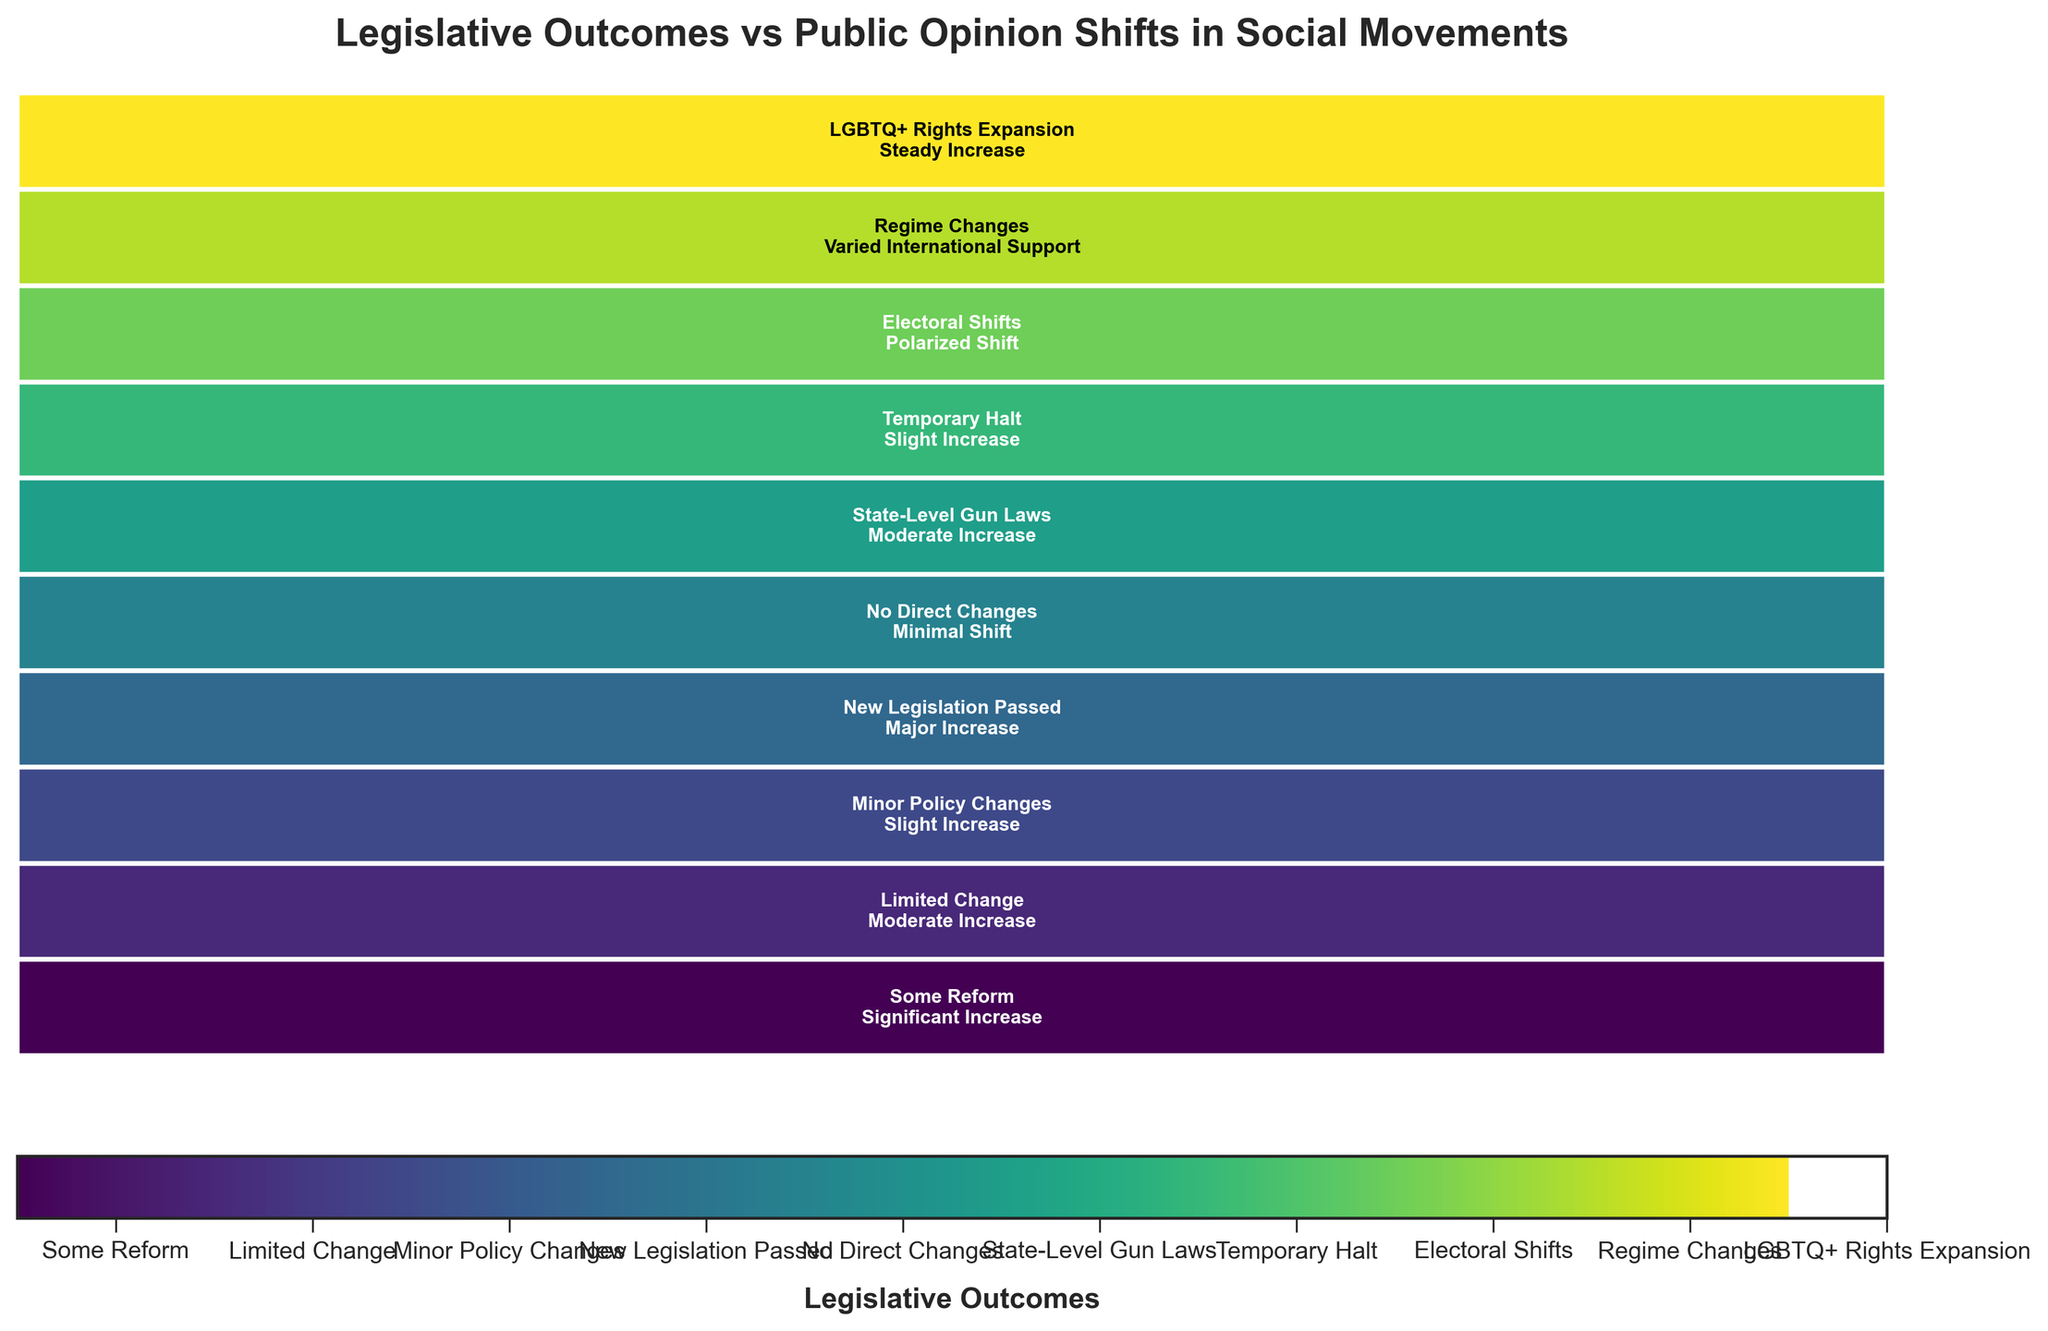What is the title of the figure? The title can be found at the top of the figure, usually in bold text.
Answer: Legislative Outcomes vs Public Opinion Shifts in Social Movements Which social movement resulted in "New Legislation Passed" for legislative outcome? Look for the label "New Legislation Passed," and identify the corresponding social movement within that section.
Answer: Me Too Which public opinion shift is associated with "Regime Changes" as the legislative outcome? Locate the section labeled "Regime Changes" and determine the associated text in that same rectangle.
Answer: Varied International Support How many movements resulted in “Limited Change” in legislative outcome? Locate the section for "Limited Change" and count the number of corresponding rectangles.
Answer: One What is the relationship between the increase in public opinion and legislative outcomes? Observe the various rectangles to note the correlation between significant increases in public opinion and the strength of legislative outcomes. Major increases in public opinion appear aligned with stronger legislative changes.
Answer: Major increases generally align with stronger legislative changes Which public opinion shift has the most diversity in legislative outcomes? Count the number of different legislative outcomes associated with each unique public opinion shift across the whole figure. The one with the most different associated outcomes has the most diversity.
Answer: Moderate Increase How do "Minor Policy Changes" compare with "New Legislation Passed" in terms of public opinion shifts? Compare the number and types of public opinion shifts for both "Minor Policy Changes" and "New Legislation Passed." Note that "New Legislation Passed" is associated with a major increase, while "Minor Policy Changes" are linked to slight increases.
Answer: New Legislation Passed has a stronger shift Which legislative outcome is associated with the most significant increase in public opinion? Identify the part of the figure where the label “Significant Increase” is dominant and check the corresponding legislative outcomes.
Answer: Some Reform Is there any social movement that led to "No Direct Changes" in legislative outcomes and what was the public opinion shift for that movement? Locate the section for “No Direct Changes” and identify the corresponding public opinion shift within the same rectangle.
Answer: Minimal Shift for Occupy Wall Street 